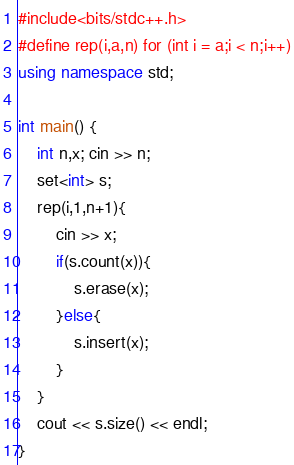Convert code to text. <code><loc_0><loc_0><loc_500><loc_500><_C++_>#include<bits/stdc++.h>
#define rep(i,a,n) for (int i = a;i < n;i++)
using namespace std;

int main() {
    int n,x; cin >> n;
    set<int> s;
    rep(i,1,n+1){
        cin >> x;
        if(s.count(x)){
            s.erase(x);
        }else{
            s.insert(x);
        }
    }
    cout << s.size() << endl;
}</code> 